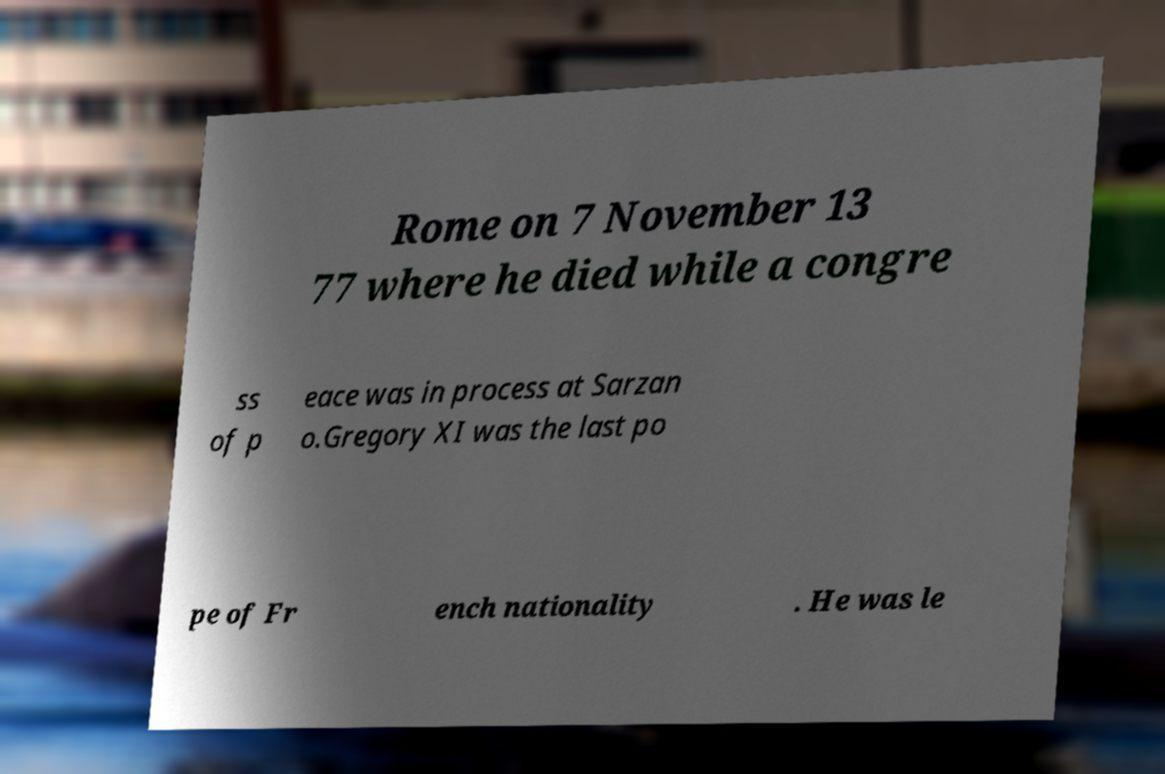What messages or text are displayed in this image? I need them in a readable, typed format. Rome on 7 November 13 77 where he died while a congre ss of p eace was in process at Sarzan o.Gregory XI was the last po pe of Fr ench nationality . He was le 